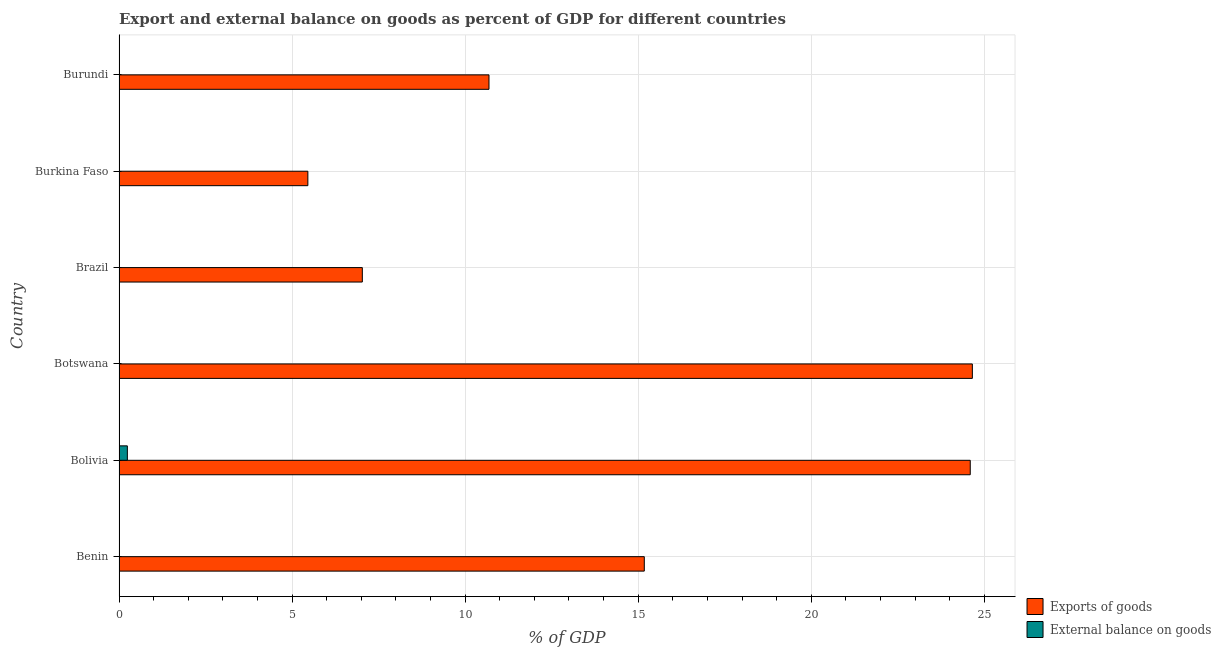How many different coloured bars are there?
Your answer should be very brief. 2. Are the number of bars on each tick of the Y-axis equal?
Your response must be concise. No. How many bars are there on the 4th tick from the bottom?
Offer a very short reply. 1. What is the label of the 5th group of bars from the top?
Make the answer very short. Bolivia. In how many cases, is the number of bars for a given country not equal to the number of legend labels?
Your answer should be very brief. 5. What is the export of goods as percentage of gdp in Benin?
Keep it short and to the point. 15.18. Across all countries, what is the maximum export of goods as percentage of gdp?
Your response must be concise. 24.66. Across all countries, what is the minimum export of goods as percentage of gdp?
Offer a very short reply. 5.46. In which country was the external balance on goods as percentage of gdp maximum?
Keep it short and to the point. Bolivia. What is the total external balance on goods as percentage of gdp in the graph?
Your answer should be very brief. 0.24. What is the difference between the export of goods as percentage of gdp in Botswana and that in Burkina Faso?
Offer a terse response. 19.2. What is the difference between the external balance on goods as percentage of gdp in Benin and the export of goods as percentage of gdp in Bolivia?
Keep it short and to the point. -24.59. What is the difference between the export of goods as percentage of gdp and external balance on goods as percentage of gdp in Bolivia?
Your answer should be very brief. 24.36. What is the ratio of the export of goods as percentage of gdp in Benin to that in Burkina Faso?
Keep it short and to the point. 2.78. Is the export of goods as percentage of gdp in Benin less than that in Burundi?
Offer a very short reply. No. What is the difference between the highest and the second highest export of goods as percentage of gdp?
Offer a very short reply. 0.06. What is the difference between the highest and the lowest external balance on goods as percentage of gdp?
Your answer should be very brief. 0.24. How many bars are there?
Offer a very short reply. 7. How many countries are there in the graph?
Your answer should be compact. 6. What is the difference between two consecutive major ticks on the X-axis?
Your answer should be compact. 5. Does the graph contain any zero values?
Keep it short and to the point. Yes. How many legend labels are there?
Your answer should be compact. 2. How are the legend labels stacked?
Your answer should be compact. Vertical. What is the title of the graph?
Offer a very short reply. Export and external balance on goods as percent of GDP for different countries. Does "current US$" appear as one of the legend labels in the graph?
Offer a terse response. No. What is the label or title of the X-axis?
Keep it short and to the point. % of GDP. What is the % of GDP of Exports of goods in Benin?
Provide a succinct answer. 15.18. What is the % of GDP in Exports of goods in Bolivia?
Provide a short and direct response. 24.59. What is the % of GDP of External balance on goods in Bolivia?
Provide a succinct answer. 0.24. What is the % of GDP of Exports of goods in Botswana?
Ensure brevity in your answer.  24.66. What is the % of GDP of External balance on goods in Botswana?
Offer a terse response. 0. What is the % of GDP in Exports of goods in Brazil?
Give a very brief answer. 7.03. What is the % of GDP of Exports of goods in Burkina Faso?
Keep it short and to the point. 5.46. What is the % of GDP of Exports of goods in Burundi?
Your answer should be compact. 10.69. What is the % of GDP in External balance on goods in Burundi?
Provide a succinct answer. 0. Across all countries, what is the maximum % of GDP in Exports of goods?
Keep it short and to the point. 24.66. Across all countries, what is the maximum % of GDP of External balance on goods?
Keep it short and to the point. 0.24. Across all countries, what is the minimum % of GDP in Exports of goods?
Your answer should be very brief. 5.46. What is the total % of GDP of Exports of goods in the graph?
Provide a succinct answer. 87.6. What is the total % of GDP of External balance on goods in the graph?
Offer a very short reply. 0.24. What is the difference between the % of GDP in Exports of goods in Benin and that in Bolivia?
Your answer should be compact. -9.42. What is the difference between the % of GDP in Exports of goods in Benin and that in Botswana?
Offer a very short reply. -9.48. What is the difference between the % of GDP in Exports of goods in Benin and that in Brazil?
Your answer should be compact. 8.15. What is the difference between the % of GDP in Exports of goods in Benin and that in Burkina Faso?
Give a very brief answer. 9.72. What is the difference between the % of GDP of Exports of goods in Benin and that in Burundi?
Your response must be concise. 4.49. What is the difference between the % of GDP of Exports of goods in Bolivia and that in Botswana?
Your answer should be compact. -0.06. What is the difference between the % of GDP of Exports of goods in Bolivia and that in Brazil?
Ensure brevity in your answer.  17.57. What is the difference between the % of GDP in Exports of goods in Bolivia and that in Burkina Faso?
Provide a succinct answer. 19.14. What is the difference between the % of GDP in Exports of goods in Bolivia and that in Burundi?
Ensure brevity in your answer.  13.91. What is the difference between the % of GDP in Exports of goods in Botswana and that in Brazil?
Provide a short and direct response. 17.63. What is the difference between the % of GDP of Exports of goods in Botswana and that in Burkina Faso?
Your answer should be compact. 19.2. What is the difference between the % of GDP of Exports of goods in Botswana and that in Burundi?
Offer a terse response. 13.97. What is the difference between the % of GDP of Exports of goods in Brazil and that in Burkina Faso?
Your answer should be very brief. 1.57. What is the difference between the % of GDP in Exports of goods in Brazil and that in Burundi?
Make the answer very short. -3.66. What is the difference between the % of GDP of Exports of goods in Burkina Faso and that in Burundi?
Your answer should be very brief. -5.23. What is the difference between the % of GDP of Exports of goods in Benin and the % of GDP of External balance on goods in Bolivia?
Ensure brevity in your answer.  14.94. What is the average % of GDP in External balance on goods per country?
Provide a short and direct response. 0.04. What is the difference between the % of GDP of Exports of goods and % of GDP of External balance on goods in Bolivia?
Make the answer very short. 24.35. What is the ratio of the % of GDP in Exports of goods in Benin to that in Bolivia?
Your answer should be compact. 0.62. What is the ratio of the % of GDP in Exports of goods in Benin to that in Botswana?
Offer a very short reply. 0.62. What is the ratio of the % of GDP in Exports of goods in Benin to that in Brazil?
Offer a terse response. 2.16. What is the ratio of the % of GDP of Exports of goods in Benin to that in Burkina Faso?
Your answer should be very brief. 2.78. What is the ratio of the % of GDP of Exports of goods in Benin to that in Burundi?
Your response must be concise. 1.42. What is the ratio of the % of GDP in Exports of goods in Bolivia to that in Botswana?
Offer a very short reply. 1. What is the ratio of the % of GDP of Exports of goods in Bolivia to that in Brazil?
Your response must be concise. 3.5. What is the ratio of the % of GDP in Exports of goods in Bolivia to that in Burkina Faso?
Provide a succinct answer. 4.51. What is the ratio of the % of GDP in Exports of goods in Bolivia to that in Burundi?
Give a very brief answer. 2.3. What is the ratio of the % of GDP of Exports of goods in Botswana to that in Brazil?
Ensure brevity in your answer.  3.51. What is the ratio of the % of GDP in Exports of goods in Botswana to that in Burkina Faso?
Provide a short and direct response. 4.52. What is the ratio of the % of GDP in Exports of goods in Botswana to that in Burundi?
Your answer should be compact. 2.31. What is the ratio of the % of GDP of Exports of goods in Brazil to that in Burkina Faso?
Your answer should be very brief. 1.29. What is the ratio of the % of GDP in Exports of goods in Brazil to that in Burundi?
Give a very brief answer. 0.66. What is the ratio of the % of GDP in Exports of goods in Burkina Faso to that in Burundi?
Provide a short and direct response. 0.51. What is the difference between the highest and the second highest % of GDP of Exports of goods?
Offer a terse response. 0.06. What is the difference between the highest and the lowest % of GDP in Exports of goods?
Offer a very short reply. 19.2. What is the difference between the highest and the lowest % of GDP in External balance on goods?
Your answer should be compact. 0.24. 